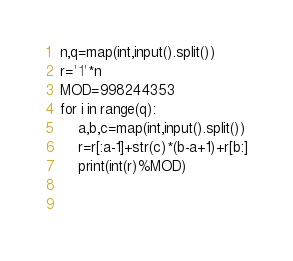<code> <loc_0><loc_0><loc_500><loc_500><_Python_>n,q=map(int,input().split())
r='1'*n
MOD=998244353
for i in range(q):
	a,b,c=map(int,input().split())
	r=r[:a-1]+str(c)*(b-a+1)+r[b:]
	print(int(r)%MOD)
	
	
</code> 